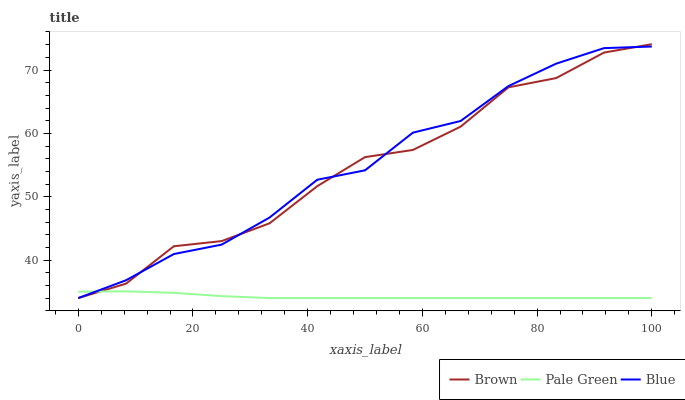Does Pale Green have the minimum area under the curve?
Answer yes or no. Yes. Does Blue have the maximum area under the curve?
Answer yes or no. Yes. Does Brown have the minimum area under the curve?
Answer yes or no. No. Does Brown have the maximum area under the curve?
Answer yes or no. No. Is Pale Green the smoothest?
Answer yes or no. Yes. Is Brown the roughest?
Answer yes or no. Yes. Is Brown the smoothest?
Answer yes or no. No. Is Pale Green the roughest?
Answer yes or no. No. Does Blue have the lowest value?
Answer yes or no. Yes. Does Brown have the highest value?
Answer yes or no. Yes. Does Pale Green have the highest value?
Answer yes or no. No. Does Pale Green intersect Brown?
Answer yes or no. Yes. Is Pale Green less than Brown?
Answer yes or no. No. Is Pale Green greater than Brown?
Answer yes or no. No. 